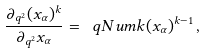Convert formula to latex. <formula><loc_0><loc_0><loc_500><loc_500>\frac { \partial _ { q ^ { 2 } } ( x _ { \alpha } ) ^ { k } } { \partial _ { q ^ { 2 } } x _ { \alpha } } = \ q N u m { k } ( x _ { \alpha } ) ^ { k - 1 } \, ,</formula> 